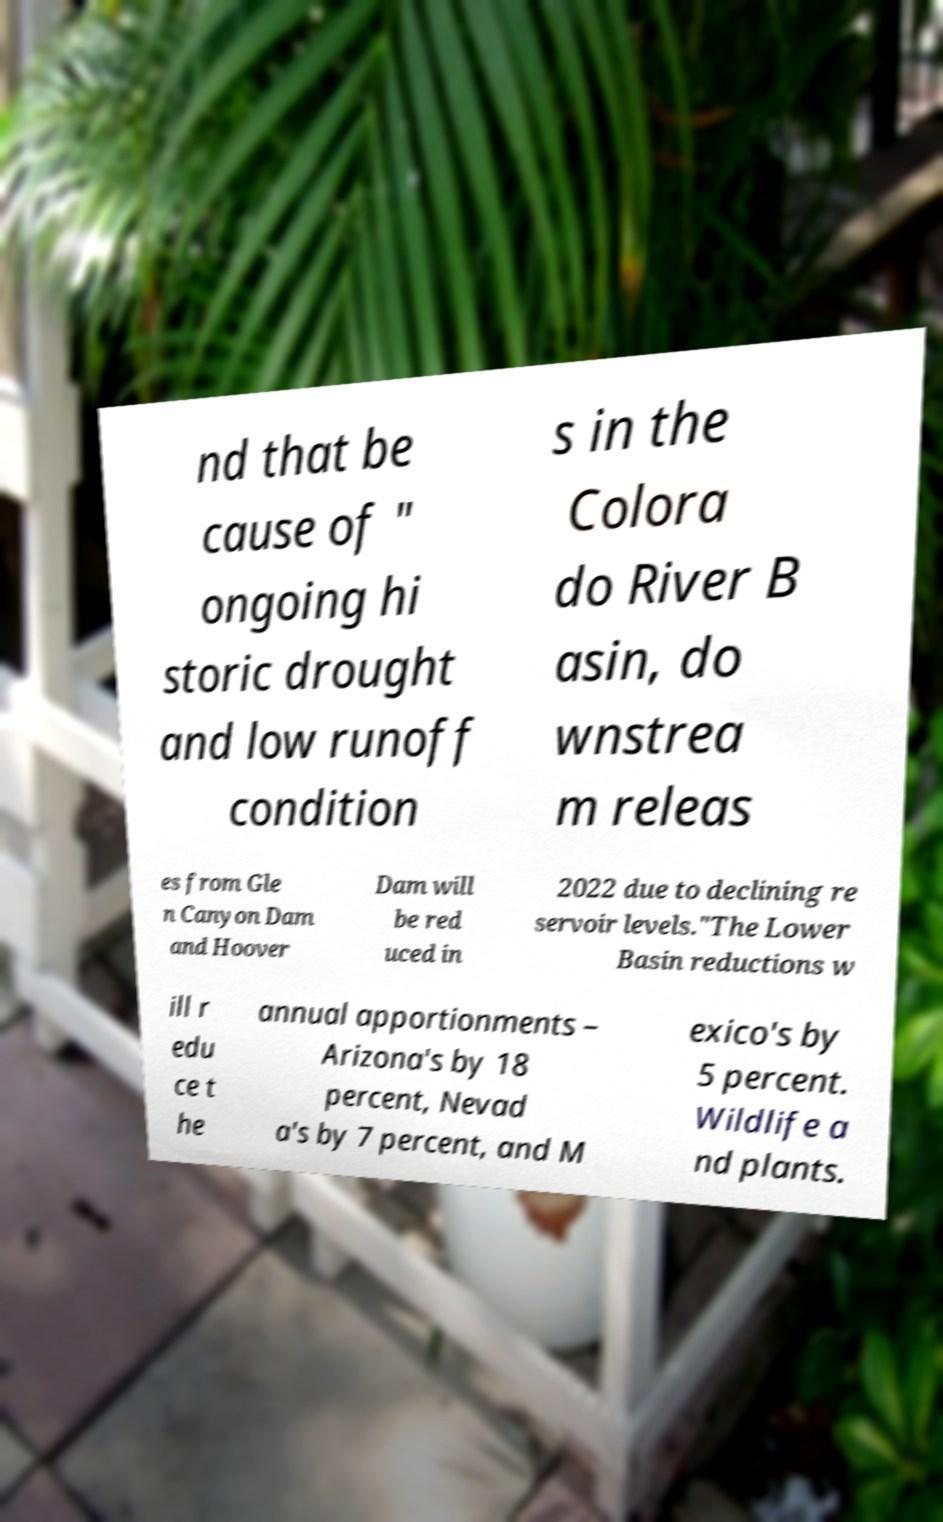Please identify and transcribe the text found in this image. nd that be cause of " ongoing hi storic drought and low runoff condition s in the Colora do River B asin, do wnstrea m releas es from Gle n Canyon Dam and Hoover Dam will be red uced in 2022 due to declining re servoir levels."The Lower Basin reductions w ill r edu ce t he annual apportionments – Arizona's by 18 percent, Nevad a's by 7 percent, and M exico's by 5 percent. Wildlife a nd plants. 